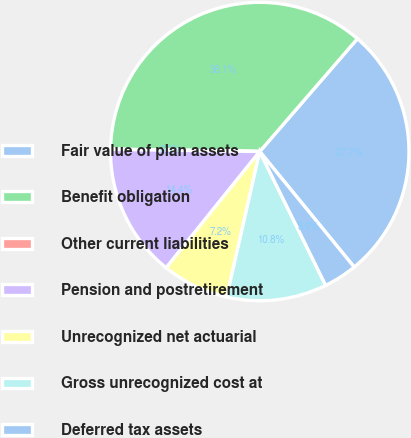<chart> <loc_0><loc_0><loc_500><loc_500><pie_chart><fcel>Fair value of plan assets<fcel>Benefit obligation<fcel>Other current liabilities<fcel>Pension and postretirement<fcel>Unrecognized net actuarial<fcel>Gross unrecognized cost at<fcel>Deferred tax assets<nl><fcel>27.74%<fcel>36.1%<fcel>0.02%<fcel>14.45%<fcel>7.23%<fcel>10.84%<fcel>3.62%<nl></chart> 